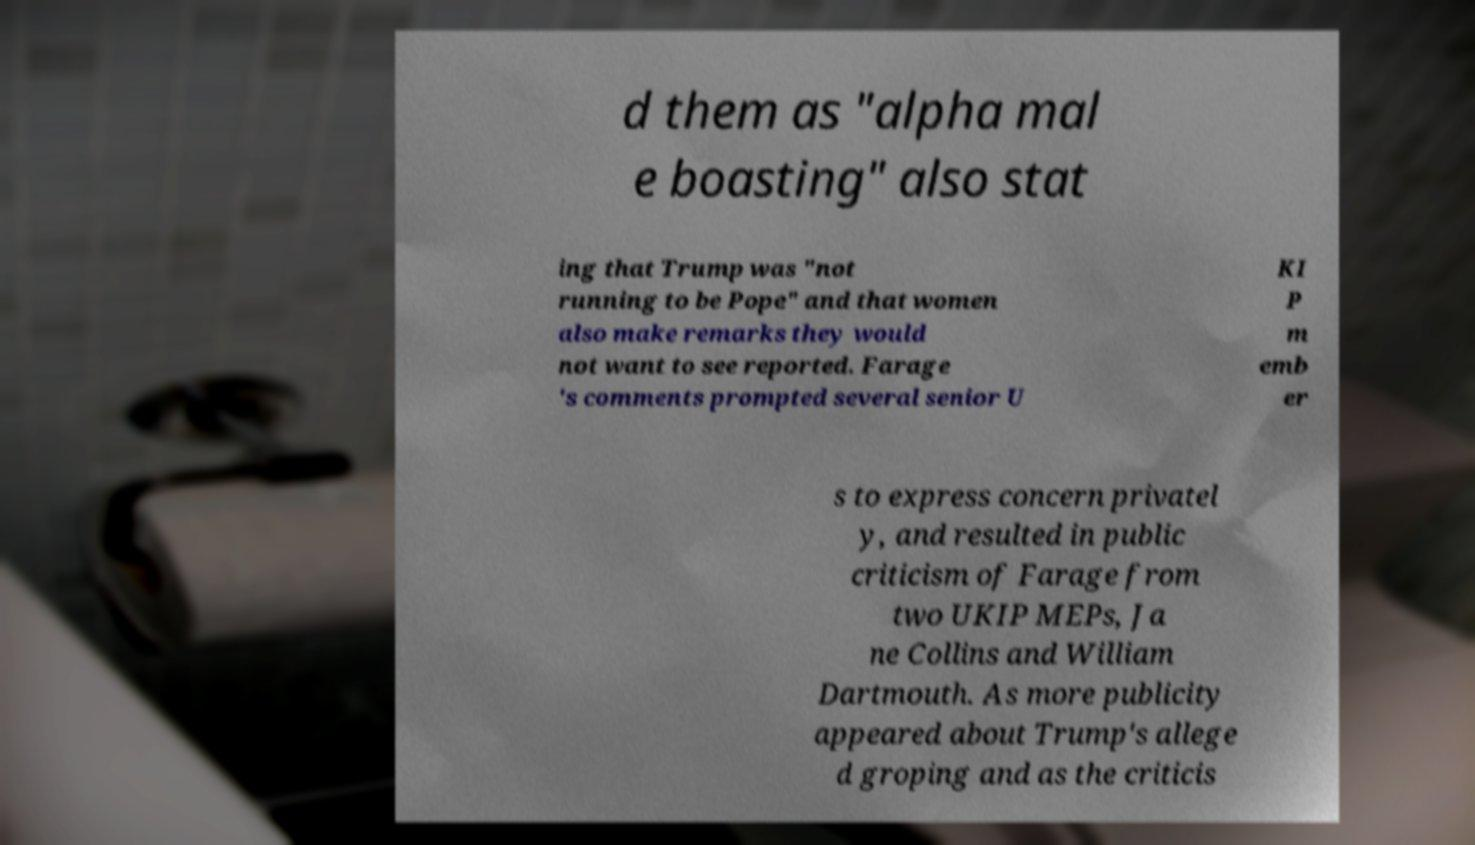For documentation purposes, I need the text within this image transcribed. Could you provide that? d them as "alpha mal e boasting" also stat ing that Trump was "not running to be Pope" and that women also make remarks they would not want to see reported. Farage 's comments prompted several senior U KI P m emb er s to express concern privatel y, and resulted in public criticism of Farage from two UKIP MEPs, Ja ne Collins and William Dartmouth. As more publicity appeared about Trump's allege d groping and as the criticis 